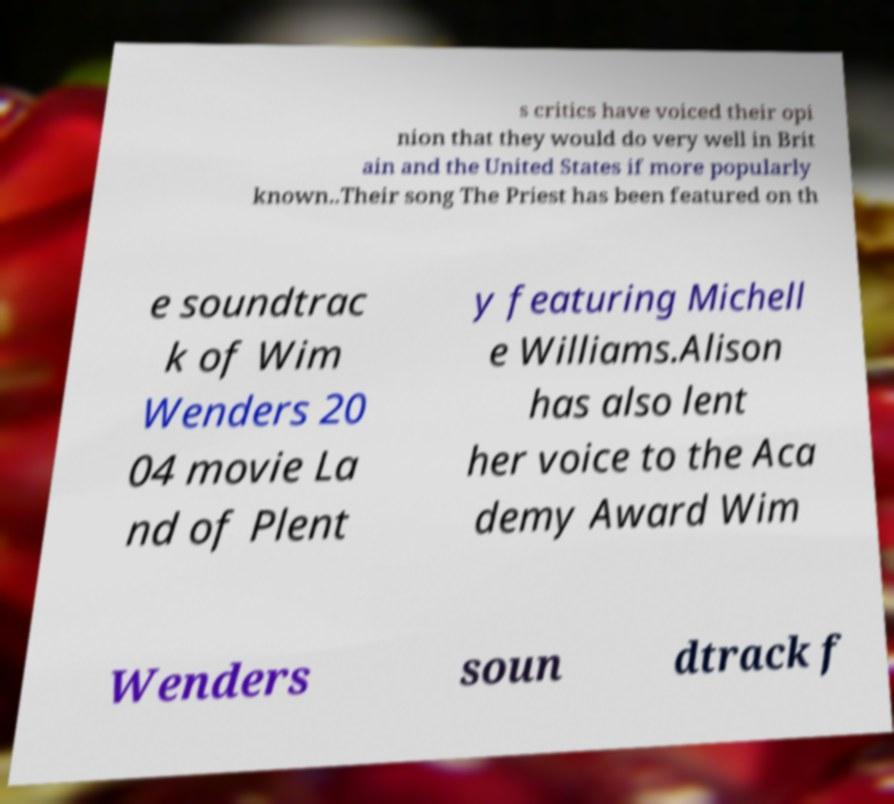I need the written content from this picture converted into text. Can you do that? s critics have voiced their opi nion that they would do very well in Brit ain and the United States if more popularly known..Their song The Priest has been featured on th e soundtrac k of Wim Wenders 20 04 movie La nd of Plent y featuring Michell e Williams.Alison has also lent her voice to the Aca demy Award Wim Wenders soun dtrack f 